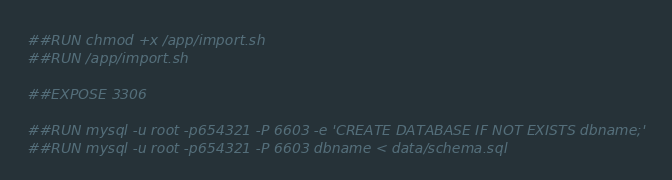Convert code to text. <code><loc_0><loc_0><loc_500><loc_500><_Dockerfile_>
##RUN chmod +x /app/import.sh
##RUN /app/import.sh

##EXPOSE 3306

##RUN mysql -u root -p654321 -P 6603 -e 'CREATE DATABASE IF NOT EXISTS dbname;'
##RUN mysql -u root -p654321 -P 6603 dbname < data/schema.sql
</code> 